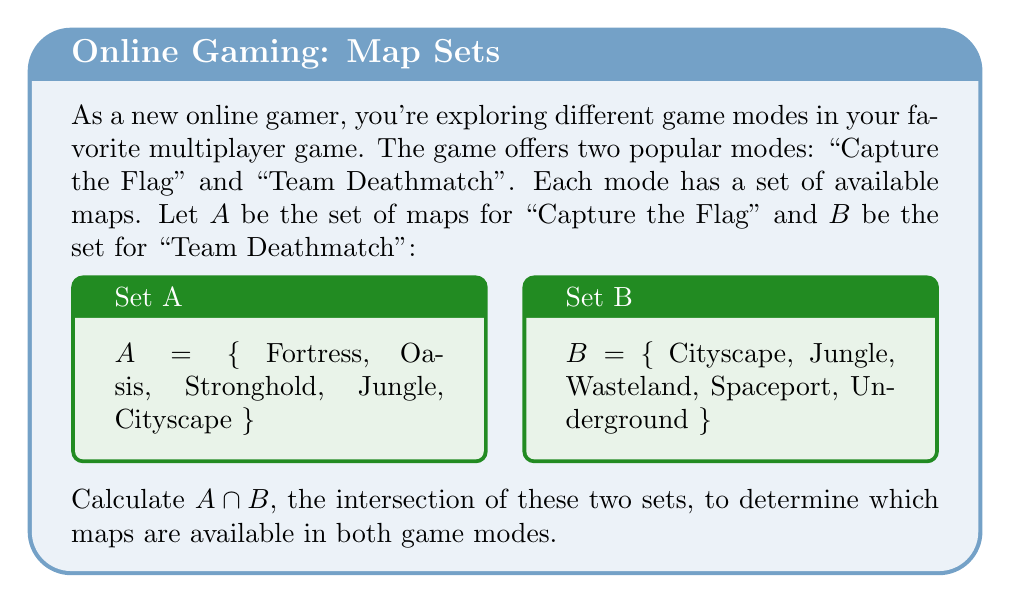Provide a solution to this math problem. To find the intersection of sets A and B, we need to identify the elements that are common to both sets. Let's follow these steps:

1. List out the elements of set A:
   A = {Fortress, Oasis, Stronghold, Jungle, Cityscape}

2. List out the elements of set B:
   B = {Cityscape, Jungle, Wasteland, Spaceport, Underground}

3. Compare the elements of both sets and identify those that appear in both:
   - Fortress: Only in A
   - Oasis: Only in A
   - Stronghold: Only in A
   - Jungle: In both A and B
   - Cityscape: In both A and B
   - Wasteland: Only in B
   - Spaceport: Only in B
   - Underground: Only in B

4. The intersection $A \cap B$ consists of the elements that appear in both sets:
   $A \cap B = \{Jungle, Cityscape\}$

Therefore, the maps "Jungle" and "Cityscape" are available in both "Capture the Flag" and "Team Deathmatch" game modes.
Answer: $A \cap B = \{Jungle, Cityscape\}$ 